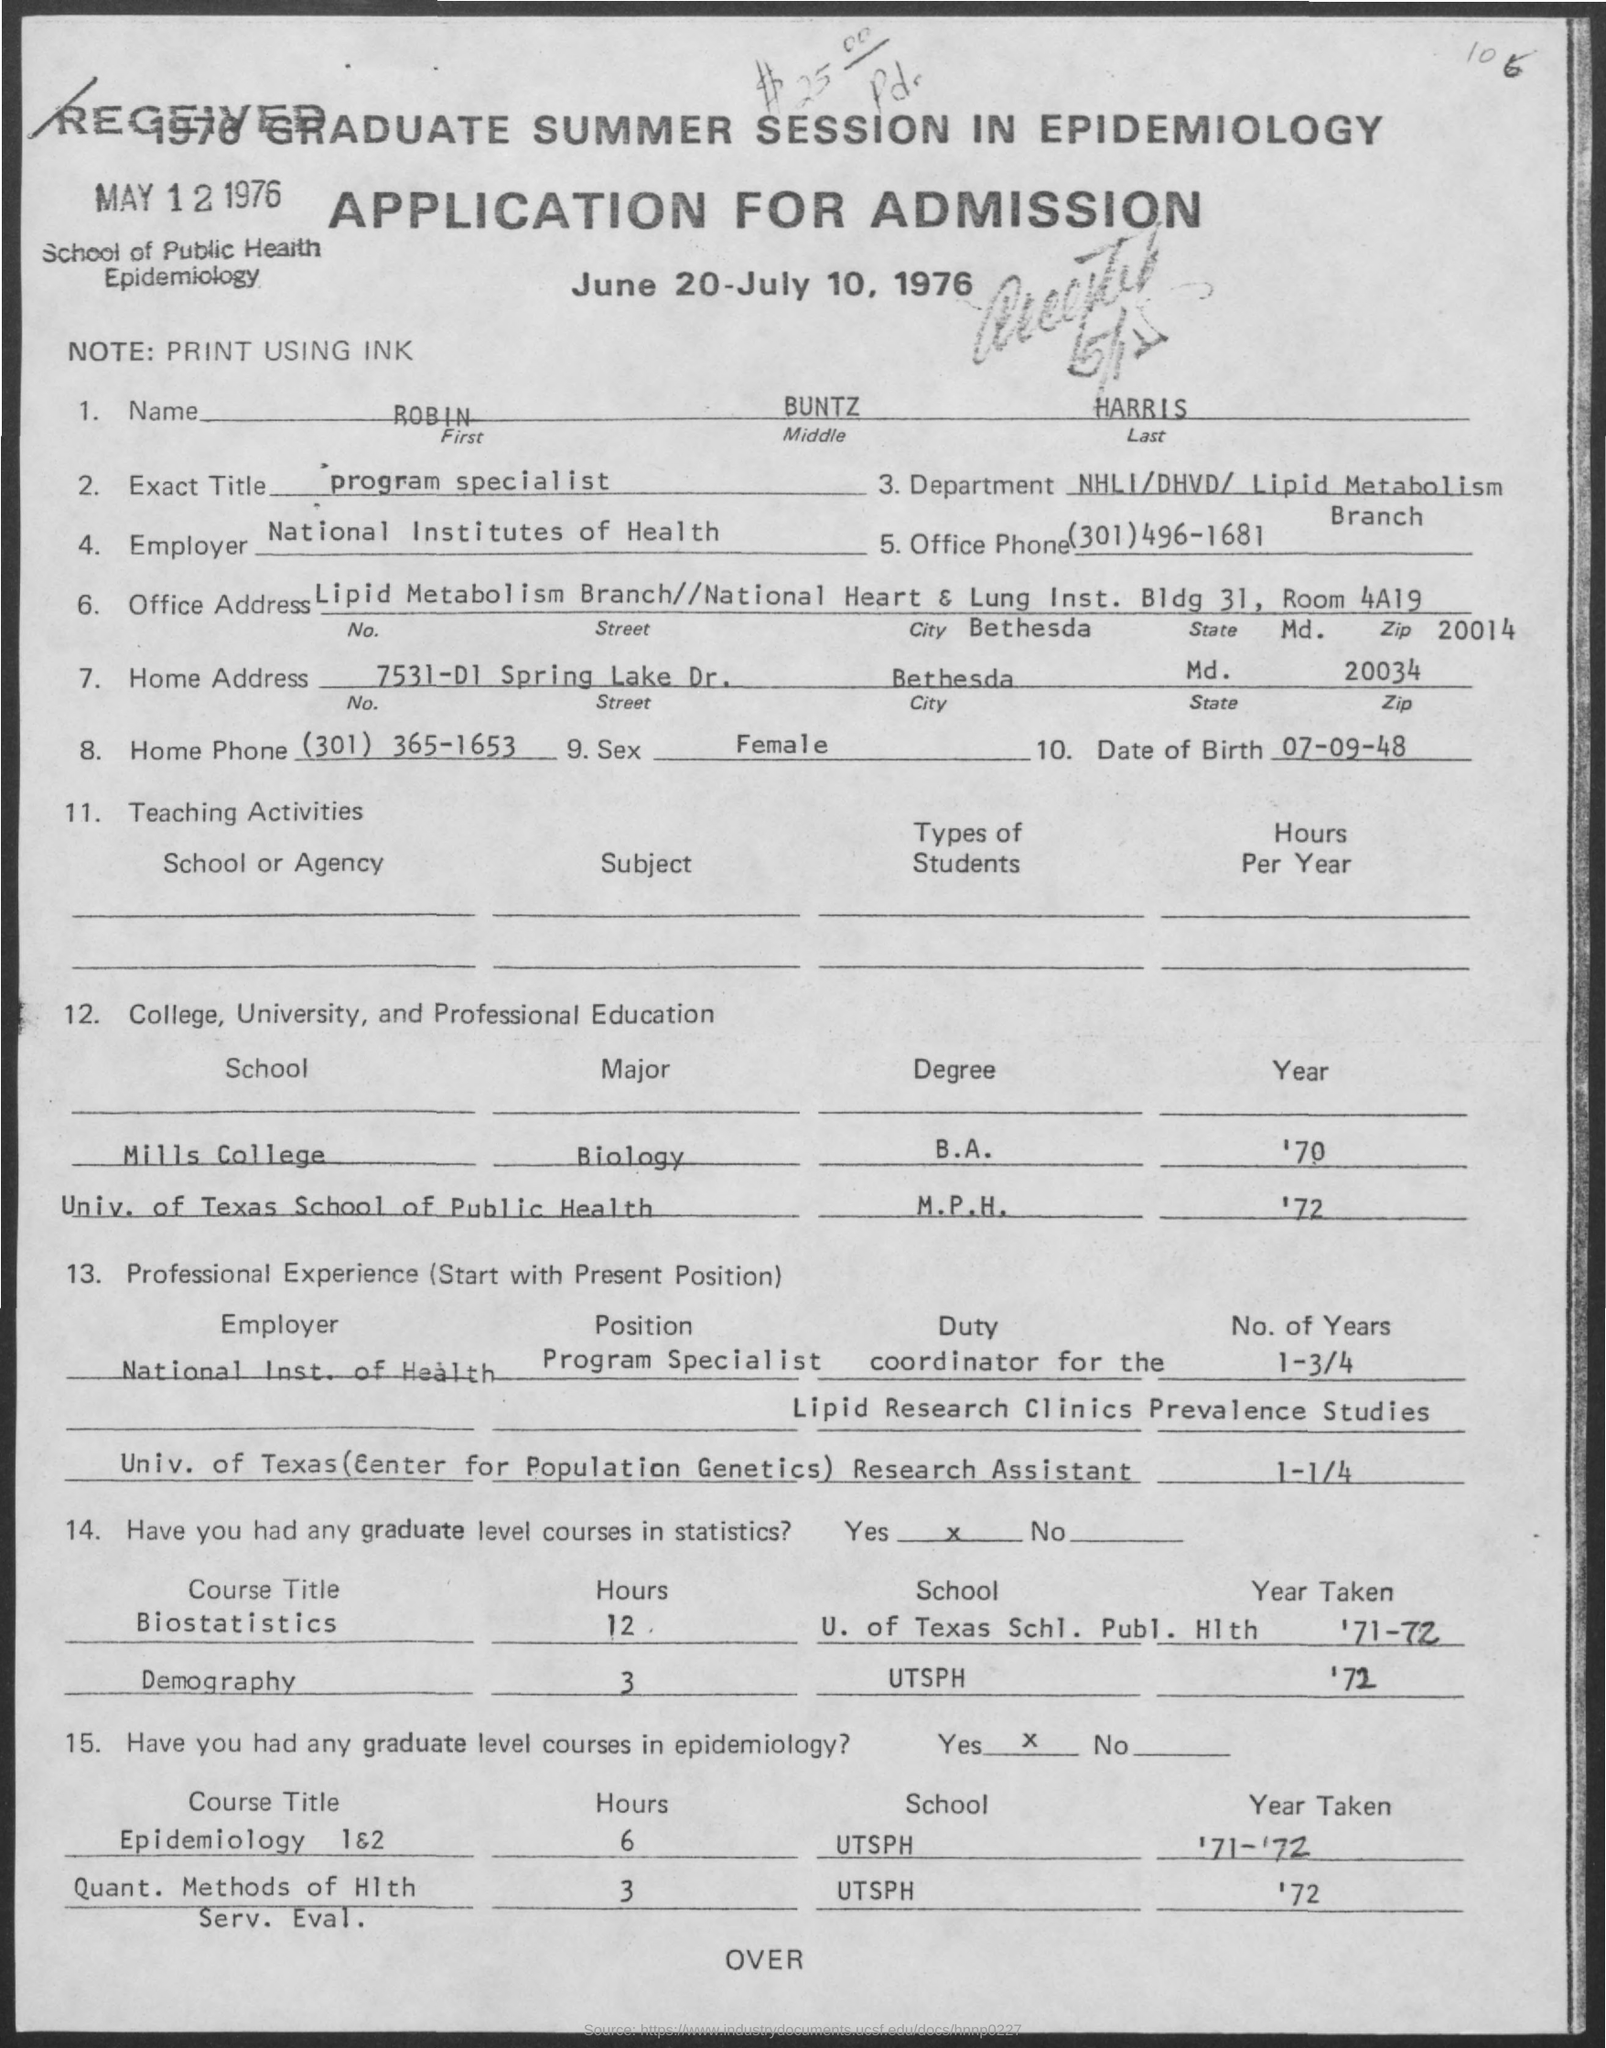What is written in the Note Field ?
Offer a very short reply. PRINT USING INK. What is written in the Exact Title Field ?
Give a very brief answer. Program specialist. Who is the Employer ?
Give a very brief answer. National Institutes of Health. What is the Home Phone Number ?
Your answer should be very brief. (301) 365-1653. What is the Date of Birth of ROBIN ?
Give a very brief answer. 07-09-48. What is written in the Sex Field ?
Keep it short and to the point. Female. 